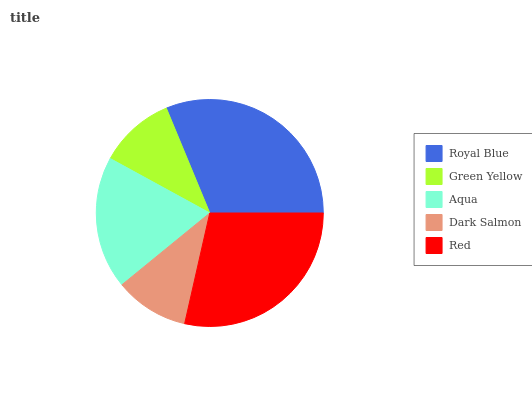Is Dark Salmon the minimum?
Answer yes or no. Yes. Is Royal Blue the maximum?
Answer yes or no. Yes. Is Green Yellow the minimum?
Answer yes or no. No. Is Green Yellow the maximum?
Answer yes or no. No. Is Royal Blue greater than Green Yellow?
Answer yes or no. Yes. Is Green Yellow less than Royal Blue?
Answer yes or no. Yes. Is Green Yellow greater than Royal Blue?
Answer yes or no. No. Is Royal Blue less than Green Yellow?
Answer yes or no. No. Is Aqua the high median?
Answer yes or no. Yes. Is Aqua the low median?
Answer yes or no. Yes. Is Green Yellow the high median?
Answer yes or no. No. Is Dark Salmon the low median?
Answer yes or no. No. 